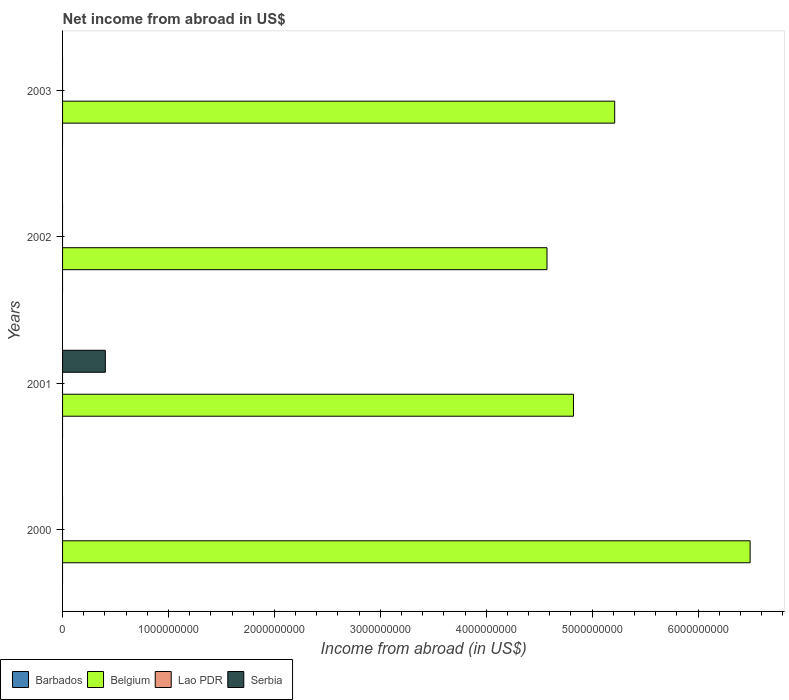How many different coloured bars are there?
Your answer should be compact. 2. What is the label of the 4th group of bars from the top?
Your answer should be compact. 2000. What is the net income from abroad in Lao PDR in 2002?
Provide a short and direct response. 0. Across all years, what is the maximum net income from abroad in Serbia?
Your answer should be compact. 4.04e+08. In which year was the net income from abroad in Serbia maximum?
Make the answer very short. 2001. What is the total net income from abroad in Barbados in the graph?
Give a very brief answer. 0. What is the difference between the net income from abroad in Belgium in 2000 and that in 2002?
Provide a succinct answer. 1.92e+09. What is the difference between the net income from abroad in Barbados in 2000 and the net income from abroad in Serbia in 2003?
Ensure brevity in your answer.  0. In the year 2001, what is the difference between the net income from abroad in Serbia and net income from abroad in Belgium?
Your answer should be very brief. -4.42e+09. What is the ratio of the net income from abroad in Belgium in 2001 to that in 2003?
Your answer should be very brief. 0.93. What is the difference between the highest and the lowest net income from abroad in Belgium?
Provide a succinct answer. 1.92e+09. In how many years, is the net income from abroad in Barbados greater than the average net income from abroad in Barbados taken over all years?
Your response must be concise. 0. Is the sum of the net income from abroad in Belgium in 2001 and 2002 greater than the maximum net income from abroad in Serbia across all years?
Provide a short and direct response. Yes. Is it the case that in every year, the sum of the net income from abroad in Barbados and net income from abroad in Serbia is greater than the sum of net income from abroad in Lao PDR and net income from abroad in Belgium?
Make the answer very short. No. How many bars are there?
Give a very brief answer. 5. How many years are there in the graph?
Make the answer very short. 4. Does the graph contain any zero values?
Offer a very short reply. Yes. Does the graph contain grids?
Ensure brevity in your answer.  No. How are the legend labels stacked?
Offer a very short reply. Horizontal. What is the title of the graph?
Provide a short and direct response. Net income from abroad in US$. Does "Brunei Darussalam" appear as one of the legend labels in the graph?
Keep it short and to the point. No. What is the label or title of the X-axis?
Make the answer very short. Income from abroad (in US$). What is the label or title of the Y-axis?
Offer a terse response. Years. What is the Income from abroad (in US$) of Belgium in 2000?
Provide a short and direct response. 6.49e+09. What is the Income from abroad (in US$) of Lao PDR in 2000?
Provide a short and direct response. 0. What is the Income from abroad (in US$) in Barbados in 2001?
Provide a short and direct response. 0. What is the Income from abroad (in US$) in Belgium in 2001?
Make the answer very short. 4.82e+09. What is the Income from abroad (in US$) in Serbia in 2001?
Provide a short and direct response. 4.04e+08. What is the Income from abroad (in US$) in Belgium in 2002?
Your answer should be compact. 4.57e+09. What is the Income from abroad (in US$) of Lao PDR in 2002?
Provide a short and direct response. 0. What is the Income from abroad (in US$) in Serbia in 2002?
Provide a short and direct response. 0. What is the Income from abroad (in US$) in Belgium in 2003?
Keep it short and to the point. 5.21e+09. What is the Income from abroad (in US$) of Lao PDR in 2003?
Provide a succinct answer. 0. What is the Income from abroad (in US$) in Serbia in 2003?
Offer a very short reply. 0. Across all years, what is the maximum Income from abroad (in US$) in Belgium?
Provide a short and direct response. 6.49e+09. Across all years, what is the maximum Income from abroad (in US$) in Serbia?
Provide a short and direct response. 4.04e+08. Across all years, what is the minimum Income from abroad (in US$) in Belgium?
Keep it short and to the point. 4.57e+09. What is the total Income from abroad (in US$) of Barbados in the graph?
Provide a short and direct response. 0. What is the total Income from abroad (in US$) of Belgium in the graph?
Provide a succinct answer. 2.11e+1. What is the total Income from abroad (in US$) in Serbia in the graph?
Make the answer very short. 4.04e+08. What is the difference between the Income from abroad (in US$) of Belgium in 2000 and that in 2001?
Provide a succinct answer. 1.67e+09. What is the difference between the Income from abroad (in US$) in Belgium in 2000 and that in 2002?
Give a very brief answer. 1.92e+09. What is the difference between the Income from abroad (in US$) of Belgium in 2000 and that in 2003?
Give a very brief answer. 1.28e+09. What is the difference between the Income from abroad (in US$) of Belgium in 2001 and that in 2002?
Your answer should be compact. 2.50e+08. What is the difference between the Income from abroad (in US$) in Belgium in 2001 and that in 2003?
Offer a very short reply. -3.89e+08. What is the difference between the Income from abroad (in US$) in Belgium in 2002 and that in 2003?
Make the answer very short. -6.39e+08. What is the difference between the Income from abroad (in US$) of Belgium in 2000 and the Income from abroad (in US$) of Serbia in 2001?
Keep it short and to the point. 6.09e+09. What is the average Income from abroad (in US$) of Belgium per year?
Offer a very short reply. 5.28e+09. What is the average Income from abroad (in US$) of Lao PDR per year?
Keep it short and to the point. 0. What is the average Income from abroad (in US$) of Serbia per year?
Provide a short and direct response. 1.01e+08. In the year 2001, what is the difference between the Income from abroad (in US$) of Belgium and Income from abroad (in US$) of Serbia?
Offer a very short reply. 4.42e+09. What is the ratio of the Income from abroad (in US$) in Belgium in 2000 to that in 2001?
Your answer should be very brief. 1.35. What is the ratio of the Income from abroad (in US$) in Belgium in 2000 to that in 2002?
Make the answer very short. 1.42. What is the ratio of the Income from abroad (in US$) in Belgium in 2000 to that in 2003?
Ensure brevity in your answer.  1.25. What is the ratio of the Income from abroad (in US$) of Belgium in 2001 to that in 2002?
Your answer should be very brief. 1.05. What is the ratio of the Income from abroad (in US$) of Belgium in 2001 to that in 2003?
Ensure brevity in your answer.  0.93. What is the ratio of the Income from abroad (in US$) in Belgium in 2002 to that in 2003?
Keep it short and to the point. 0.88. What is the difference between the highest and the second highest Income from abroad (in US$) in Belgium?
Ensure brevity in your answer.  1.28e+09. What is the difference between the highest and the lowest Income from abroad (in US$) of Belgium?
Provide a succinct answer. 1.92e+09. What is the difference between the highest and the lowest Income from abroad (in US$) of Serbia?
Offer a very short reply. 4.04e+08. 